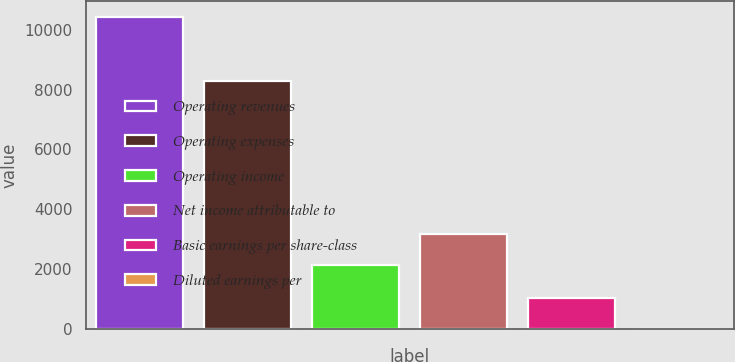<chart> <loc_0><loc_0><loc_500><loc_500><bar_chart><fcel>Operating revenues<fcel>Operating expenses<fcel>Operating income<fcel>Net income attributable to<fcel>Basic earnings per share-class<fcel>Diluted earnings per<nl><fcel>10421<fcel>8282<fcel>2139<fcel>3180.78<fcel>1044.94<fcel>3.16<nl></chart> 